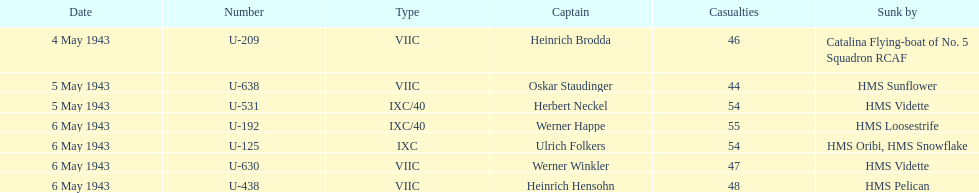Which u-boat had more than 54 casualties? U-192. 